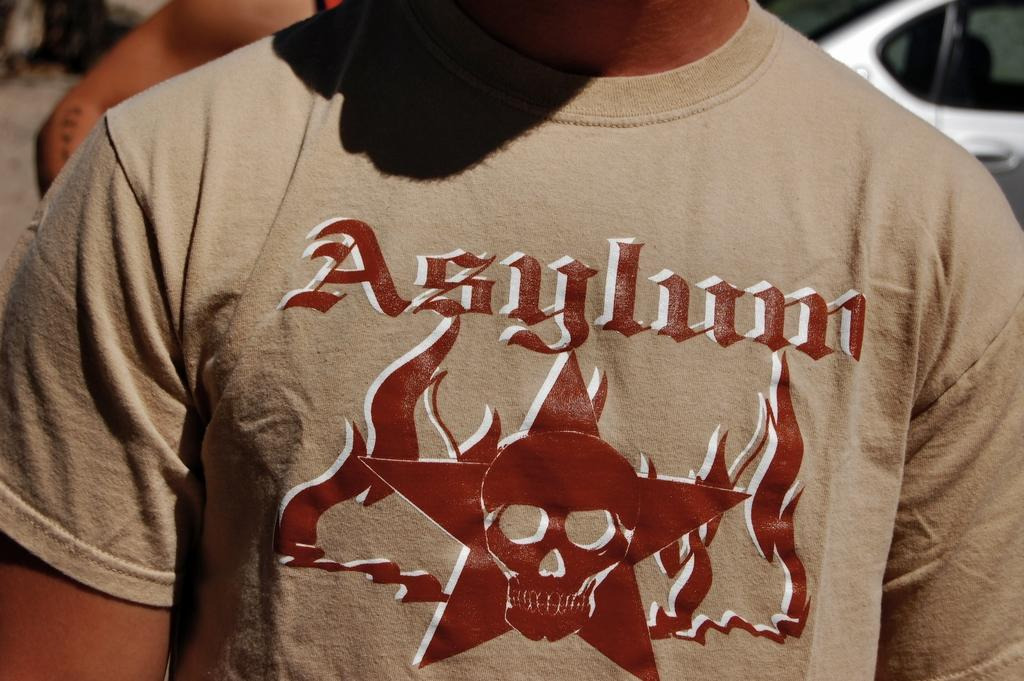<image>
Render a clear and concise summary of the photo. A light brown t-shirt that reads "Asylum" and has a star and a skull as well. 